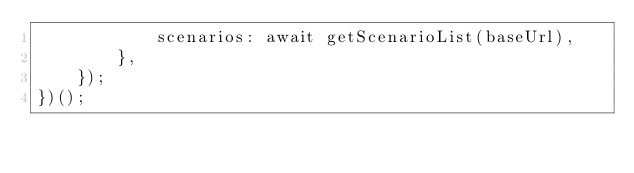<code> <loc_0><loc_0><loc_500><loc_500><_JavaScript_>            scenarios: await getScenarioList(baseUrl),
        },
    });
})();
</code> 